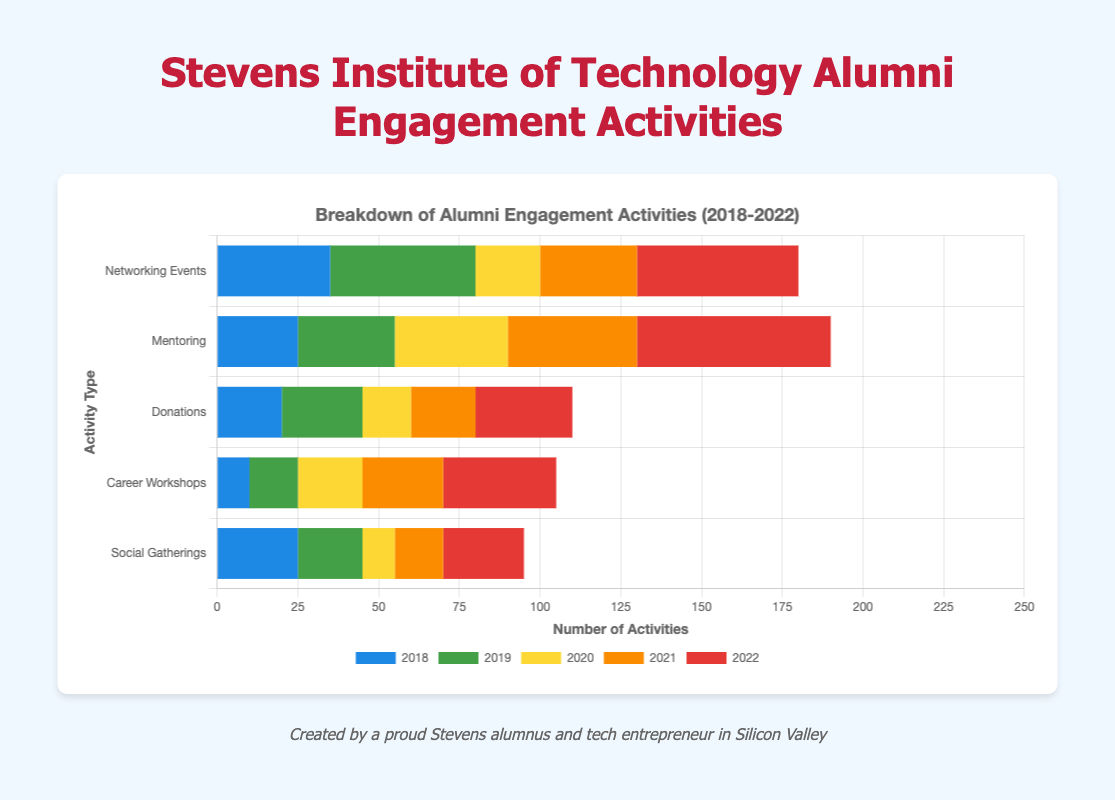What type of engagement activity had the highest number in 2022? By observing the bar lengths for each type of activity in 2022, the "Mentoring" bar is the longest, indicating it had the highest number of activities.
Answer: Mentoring Which year had the most alumni activities in total for Networking Events? Sum the values for Networking Events across all years: 35 (2018) + 45 (2019) + 20 (2020) + 30 (2021) + 50 (2022). The total is highest in 2022.
Answer: 2022 When was the lowest participation in Social Gatherings? Observe the bar lengths for Social Gatherings; the shortest bar corresponds to 2020.
Answer: 2020 What is the total number of Mentoring activities from 2018 to 2022? Sum the numbers for each year for Mentoring: 25 (2018) + 30 (2019) + 35 (2020) + 40 (2021) + 60 (2022). The total is 190.
Answer: 190 Compare the number of Donations in 2018 and 2022. In which year was it higher? Compare the lengths of the bars for Donations in 2018 and 2022. The bar for 2022 is longer.
Answer: 2022 How much did Career Workshops increase from 2018 to 2022? Subtract the number of Career Workshops in 2018 from the number in 2022: 35 (2022) - 10 (2018) = 25.
Answer: 25 Which two years had an equal number of Social Gatherings? Compare the lengths of the bars for Social Gatherings across the years; 2018 and 2022 have equal lengths.
Answer: 2018 and 2022 What was the average number of Networking Events per year from 2018 to 2022? Sum the values of Networking Events for all years and divide by the number of years: (35 + 45 + 20 + 30 + 50) / 5 = 36.
Answer: 36 In which year did Mentoring exceed the number of Networking Events for the first time? Compare the bars of Mentoring and Networking Events each year until Mentoring's bar is longer than Networking's. This first occurs in 2020.
Answer: 2020 